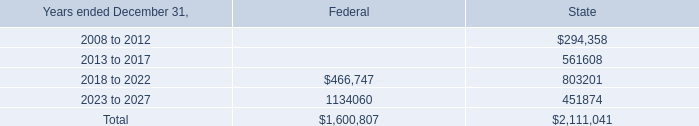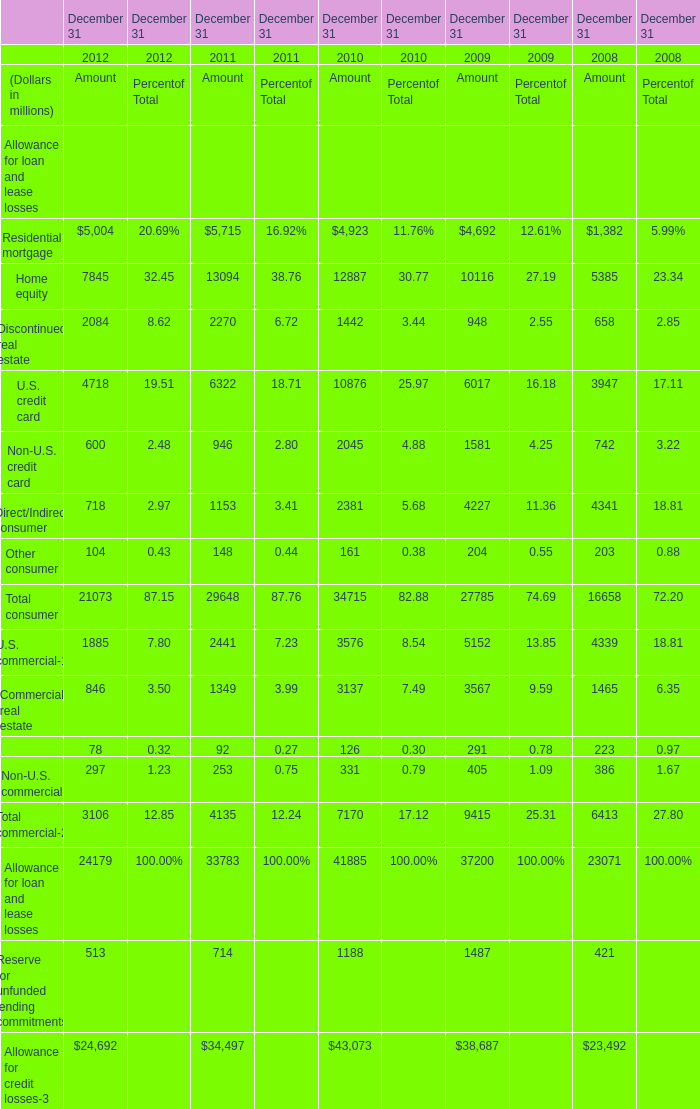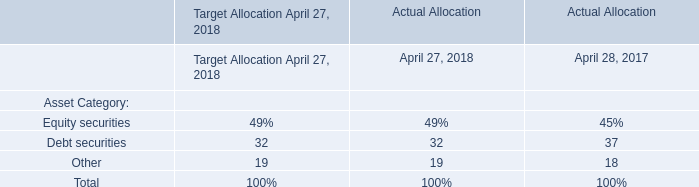What is the average amount of Home equity of December 31 2010 Amount, and 2018 to 2022 of State ? 
Computations: ((12887.0 + 803201.0) / 2)
Answer: 408044.0. 